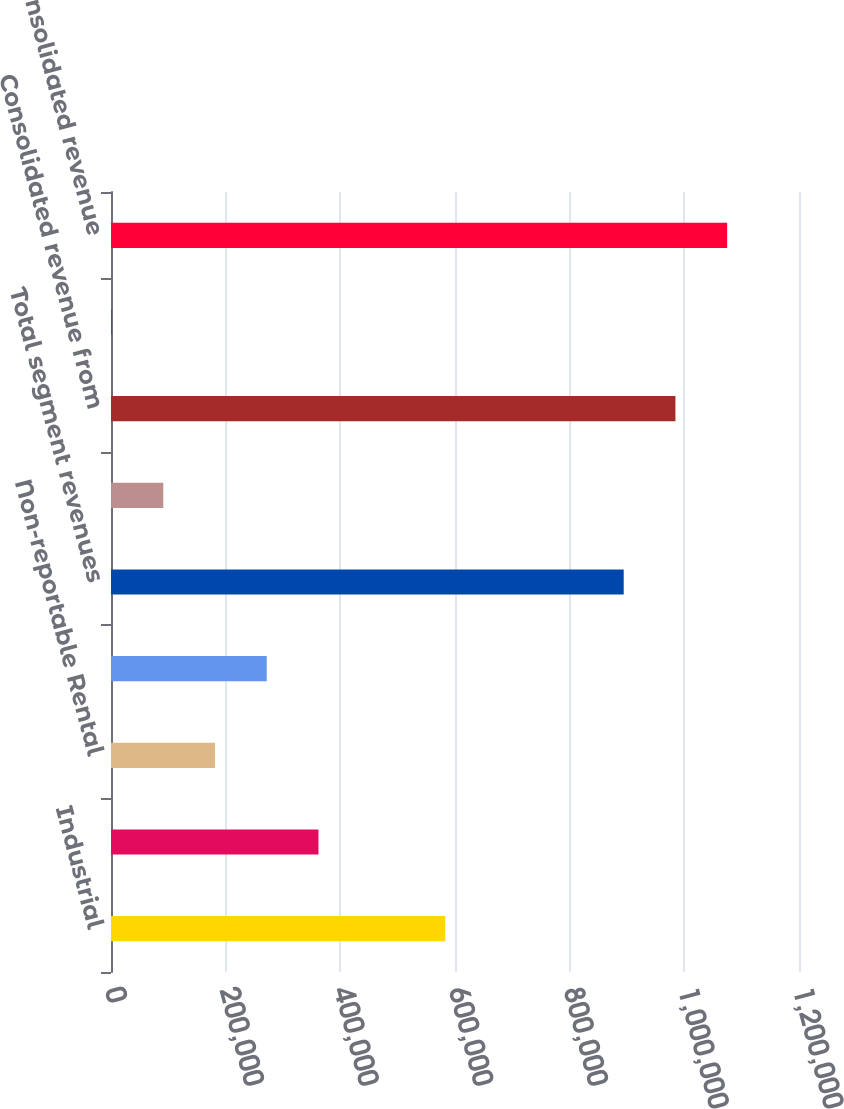<chart> <loc_0><loc_0><loc_500><loc_500><bar_chart><fcel>Industrial<fcel>Medical Office<fcel>Non-reportable Rental<fcel>Service Operations<fcel>Total segment revenues<fcel>Other revenue<fcel>Consolidated revenue from<fcel>Discontinued operations<fcel>Consolidated revenue<nl><fcel>583019<fcel>361881<fcel>181432<fcel>271656<fcel>894246<fcel>91207.4<fcel>984470<fcel>983<fcel>1.07469e+06<nl></chart> 